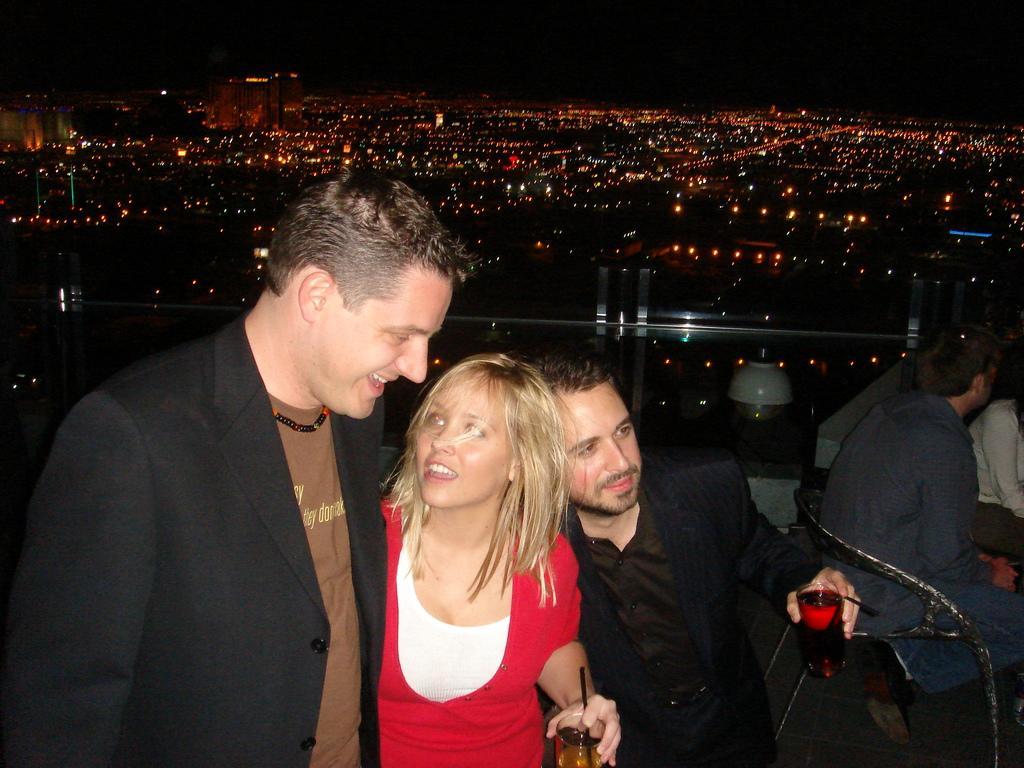How would you summarize this image in a sentence or two? In this picture we can see three people are smiling, some people are sitting on chairs, glasses with drinks, straws in it and in the background we can see buildings, lights, some objects and it is dark. 